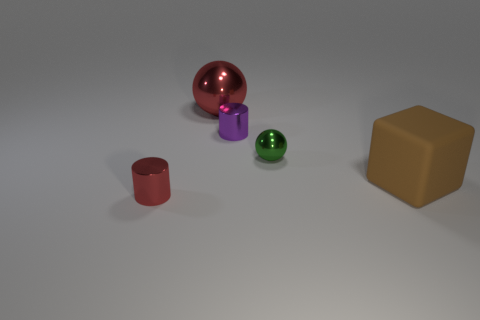There is a object to the left of the large shiny object; what is its shape?
Your answer should be very brief. Cylinder. What is the size of the purple cylinder that is the same material as the tiny red thing?
Your answer should be compact. Small. What number of other matte objects are the same shape as the tiny purple object?
Ensure brevity in your answer.  0. Is the color of the small shiny cylinder that is to the left of the large red metal ball the same as the large metal sphere?
Your answer should be compact. Yes. There is a small shiny cylinder in front of the large thing in front of the tiny green sphere; what number of matte objects are in front of it?
Ensure brevity in your answer.  0. What number of metallic cylinders are on the left side of the large red shiny sphere and behind the tiny red cylinder?
Your response must be concise. 0. What is the shape of the metal thing that is the same color as the big ball?
Give a very brief answer. Cylinder. Are there any other things that have the same material as the purple thing?
Your answer should be compact. Yes. Is the material of the tiny red cylinder the same as the tiny green object?
Your answer should be very brief. Yes. What shape is the small thing that is left of the red object that is on the right side of the tiny metallic object to the left of the purple metal object?
Keep it short and to the point. Cylinder. 